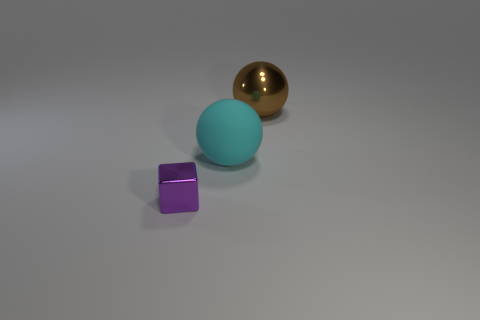Add 2 big cyan matte balls. How many objects exist? 5 Subtract 1 balls. How many balls are left? 1 Subtract all balls. How many objects are left? 1 Subtract all cyan blocks. Subtract all gray cylinders. How many blocks are left? 1 Subtract all small blue matte objects. Subtract all big brown things. How many objects are left? 2 Add 1 metal blocks. How many metal blocks are left? 2 Add 3 large objects. How many large objects exist? 5 Subtract 0 blue cubes. How many objects are left? 3 